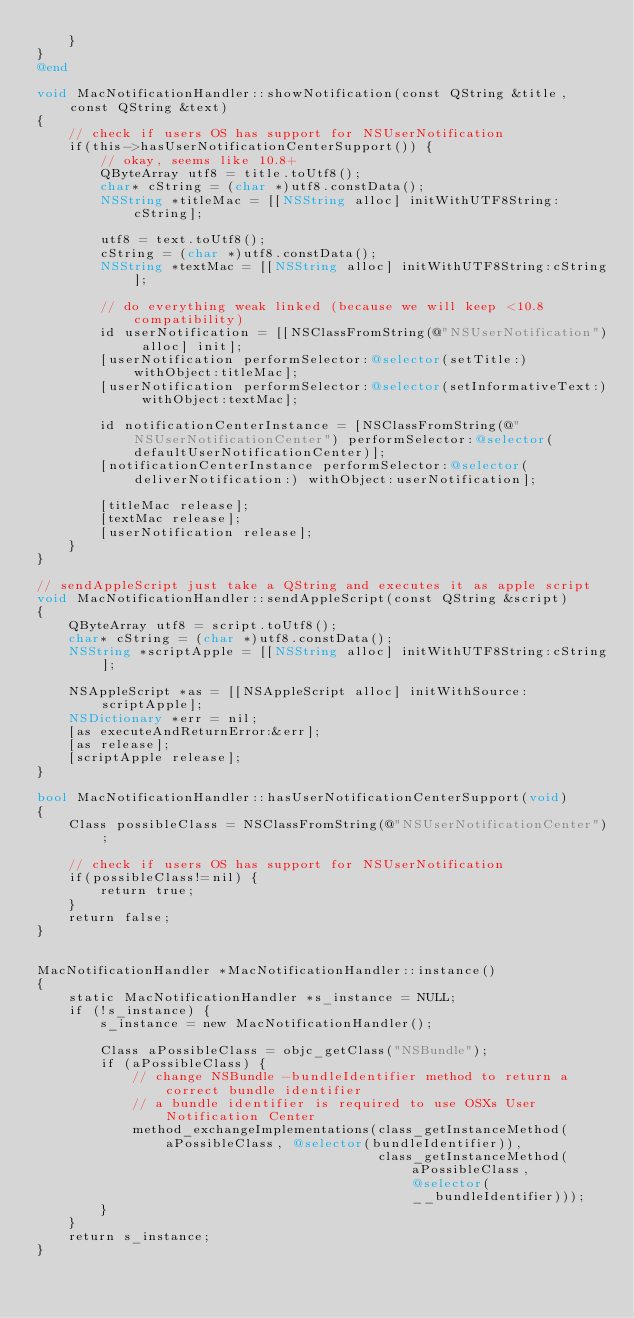<code> <loc_0><loc_0><loc_500><loc_500><_ObjectiveC_>    }
}
@end

void MacNotificationHandler::showNotification(const QString &title, const QString &text)
{
    // check if users OS has support for NSUserNotification
    if(this->hasUserNotificationCenterSupport()) {
        // okay, seems like 10.8+
        QByteArray utf8 = title.toUtf8();
        char* cString = (char *)utf8.constData();
        NSString *titleMac = [[NSString alloc] initWithUTF8String:cString];

        utf8 = text.toUtf8();
        cString = (char *)utf8.constData();
        NSString *textMac = [[NSString alloc] initWithUTF8String:cString];

        // do everything weak linked (because we will keep <10.8 compatibility)
        id userNotification = [[NSClassFromString(@"NSUserNotification") alloc] init];
        [userNotification performSelector:@selector(setTitle:) withObject:titleMac];
        [userNotification performSelector:@selector(setInformativeText:) withObject:textMac];

        id notificationCenterInstance = [NSClassFromString(@"NSUserNotificationCenter") performSelector:@selector(defaultUserNotificationCenter)];
        [notificationCenterInstance performSelector:@selector(deliverNotification:) withObject:userNotification];

        [titleMac release];
        [textMac release];
        [userNotification release];
    }
}

// sendAppleScript just take a QString and executes it as apple script
void MacNotificationHandler::sendAppleScript(const QString &script)
{
    QByteArray utf8 = script.toUtf8();
    char* cString = (char *)utf8.constData();
    NSString *scriptApple = [[NSString alloc] initWithUTF8String:cString];

    NSAppleScript *as = [[NSAppleScript alloc] initWithSource:scriptApple];
    NSDictionary *err = nil;
    [as executeAndReturnError:&err];
    [as release];
    [scriptApple release];
}

bool MacNotificationHandler::hasUserNotificationCenterSupport(void)
{
    Class possibleClass = NSClassFromString(@"NSUserNotificationCenter");

    // check if users OS has support for NSUserNotification
    if(possibleClass!=nil) {
        return true;
    }
    return false;
}


MacNotificationHandler *MacNotificationHandler::instance()
{
    static MacNotificationHandler *s_instance = NULL;
    if (!s_instance) {
        s_instance = new MacNotificationHandler();
        
        Class aPossibleClass = objc_getClass("NSBundle");
        if (aPossibleClass) {
            // change NSBundle -bundleIdentifier method to return a correct bundle identifier
            // a bundle identifier is required to use OSXs User Notification Center
            method_exchangeImplementations(class_getInstanceMethod(aPossibleClass, @selector(bundleIdentifier)),
                                           class_getInstanceMethod(aPossibleClass, @selector(__bundleIdentifier)));
        }
    }
    return s_instance;
}
</code> 